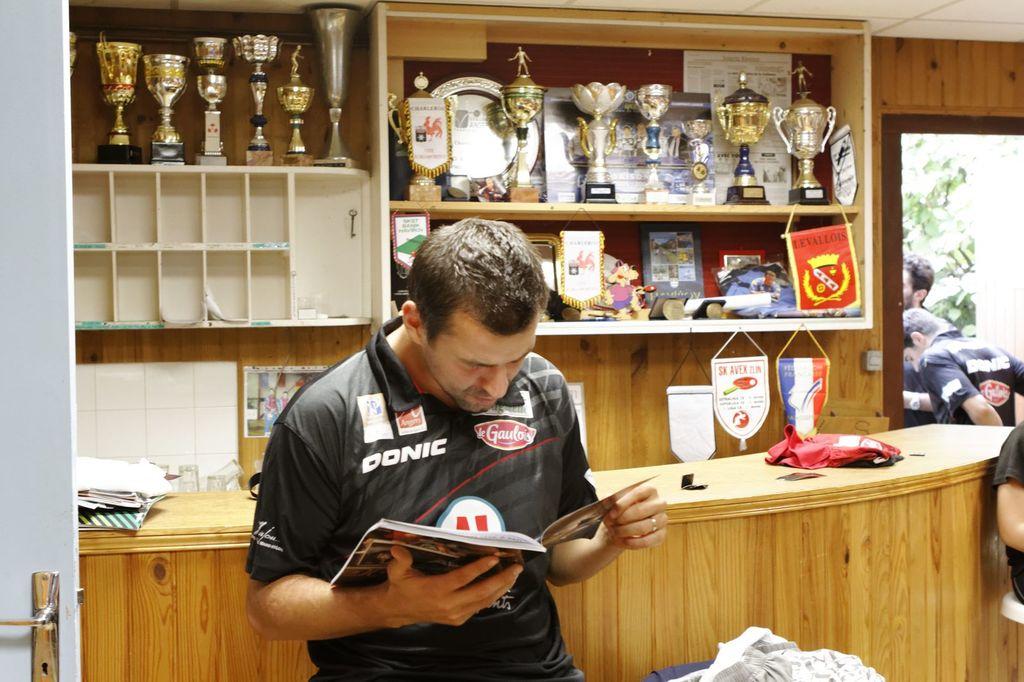What brand is on the man's shirt above his right breast?
Provide a short and direct response. Donic. 